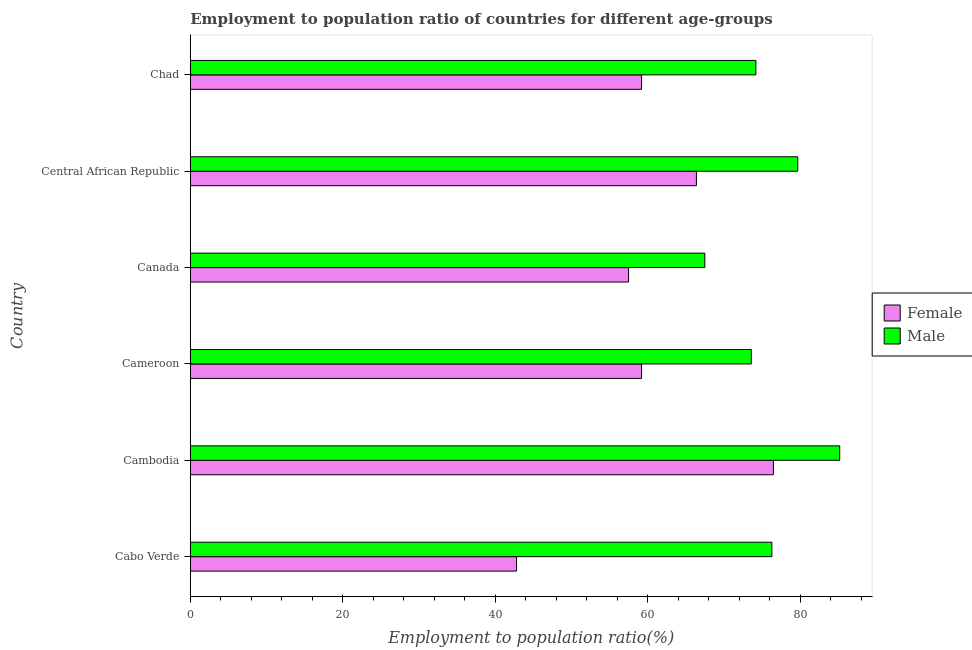Are the number of bars per tick equal to the number of legend labels?
Offer a very short reply. Yes. Are the number of bars on each tick of the Y-axis equal?
Make the answer very short. Yes. How many bars are there on the 4th tick from the bottom?
Provide a short and direct response. 2. What is the label of the 6th group of bars from the top?
Give a very brief answer. Cabo Verde. In how many cases, is the number of bars for a given country not equal to the number of legend labels?
Make the answer very short. 0. What is the employment to population ratio(female) in Cabo Verde?
Ensure brevity in your answer.  42.8. Across all countries, what is the maximum employment to population ratio(male)?
Ensure brevity in your answer.  85.2. Across all countries, what is the minimum employment to population ratio(male)?
Provide a succinct answer. 67.5. In which country was the employment to population ratio(male) maximum?
Keep it short and to the point. Cambodia. In which country was the employment to population ratio(male) minimum?
Your answer should be compact. Canada. What is the total employment to population ratio(male) in the graph?
Make the answer very short. 456.5. What is the difference between the employment to population ratio(female) in Central African Republic and the employment to population ratio(male) in Cambodia?
Your answer should be compact. -18.8. What is the average employment to population ratio(female) per country?
Provide a short and direct response. 60.27. What is the difference between the employment to population ratio(male) and employment to population ratio(female) in Cabo Verde?
Provide a succinct answer. 33.5. What is the ratio of the employment to population ratio(female) in Cabo Verde to that in Central African Republic?
Ensure brevity in your answer.  0.65. Is the employment to population ratio(female) in Cabo Verde less than that in Cameroon?
Ensure brevity in your answer.  Yes. Is the difference between the employment to population ratio(male) in Cabo Verde and Canada greater than the difference between the employment to population ratio(female) in Cabo Verde and Canada?
Give a very brief answer. Yes. What is the difference between the highest and the second highest employment to population ratio(male)?
Provide a short and direct response. 5.5. Is the sum of the employment to population ratio(female) in Cambodia and Canada greater than the maximum employment to population ratio(male) across all countries?
Ensure brevity in your answer.  Yes. How many countries are there in the graph?
Make the answer very short. 6. What is the difference between two consecutive major ticks on the X-axis?
Provide a short and direct response. 20. Are the values on the major ticks of X-axis written in scientific E-notation?
Keep it short and to the point. No. Does the graph contain grids?
Your response must be concise. No. Where does the legend appear in the graph?
Your answer should be very brief. Center right. How many legend labels are there?
Your answer should be compact. 2. What is the title of the graph?
Give a very brief answer. Employment to population ratio of countries for different age-groups. What is the label or title of the X-axis?
Ensure brevity in your answer.  Employment to population ratio(%). What is the label or title of the Y-axis?
Your response must be concise. Country. What is the Employment to population ratio(%) in Female in Cabo Verde?
Give a very brief answer. 42.8. What is the Employment to population ratio(%) in Male in Cabo Verde?
Keep it short and to the point. 76.3. What is the Employment to population ratio(%) of Female in Cambodia?
Offer a terse response. 76.5. What is the Employment to population ratio(%) in Male in Cambodia?
Offer a terse response. 85.2. What is the Employment to population ratio(%) of Female in Cameroon?
Give a very brief answer. 59.2. What is the Employment to population ratio(%) of Male in Cameroon?
Provide a succinct answer. 73.6. What is the Employment to population ratio(%) in Female in Canada?
Your answer should be very brief. 57.5. What is the Employment to population ratio(%) of Male in Canada?
Keep it short and to the point. 67.5. What is the Employment to population ratio(%) of Female in Central African Republic?
Make the answer very short. 66.4. What is the Employment to population ratio(%) of Male in Central African Republic?
Offer a terse response. 79.7. What is the Employment to population ratio(%) of Female in Chad?
Your answer should be very brief. 59.2. What is the Employment to population ratio(%) in Male in Chad?
Your response must be concise. 74.2. Across all countries, what is the maximum Employment to population ratio(%) in Female?
Your answer should be compact. 76.5. Across all countries, what is the maximum Employment to population ratio(%) in Male?
Offer a terse response. 85.2. Across all countries, what is the minimum Employment to population ratio(%) in Female?
Give a very brief answer. 42.8. Across all countries, what is the minimum Employment to population ratio(%) in Male?
Your answer should be very brief. 67.5. What is the total Employment to population ratio(%) in Female in the graph?
Your response must be concise. 361.6. What is the total Employment to population ratio(%) in Male in the graph?
Offer a terse response. 456.5. What is the difference between the Employment to population ratio(%) in Female in Cabo Verde and that in Cambodia?
Provide a short and direct response. -33.7. What is the difference between the Employment to population ratio(%) in Female in Cabo Verde and that in Cameroon?
Provide a succinct answer. -16.4. What is the difference between the Employment to population ratio(%) of Male in Cabo Verde and that in Cameroon?
Give a very brief answer. 2.7. What is the difference between the Employment to population ratio(%) in Female in Cabo Verde and that in Canada?
Ensure brevity in your answer.  -14.7. What is the difference between the Employment to population ratio(%) in Male in Cabo Verde and that in Canada?
Provide a short and direct response. 8.8. What is the difference between the Employment to population ratio(%) of Female in Cabo Verde and that in Central African Republic?
Offer a very short reply. -23.6. What is the difference between the Employment to population ratio(%) in Female in Cabo Verde and that in Chad?
Your answer should be very brief. -16.4. What is the difference between the Employment to population ratio(%) in Male in Cabo Verde and that in Chad?
Offer a terse response. 2.1. What is the difference between the Employment to population ratio(%) in Male in Cambodia and that in Canada?
Keep it short and to the point. 17.7. What is the difference between the Employment to population ratio(%) in Male in Cambodia and that in Central African Republic?
Give a very brief answer. 5.5. What is the difference between the Employment to population ratio(%) in Female in Cambodia and that in Chad?
Provide a short and direct response. 17.3. What is the difference between the Employment to population ratio(%) of Male in Cambodia and that in Chad?
Provide a succinct answer. 11. What is the difference between the Employment to population ratio(%) of Male in Cameroon and that in Canada?
Give a very brief answer. 6.1. What is the difference between the Employment to population ratio(%) in Female in Canada and that in Central African Republic?
Your response must be concise. -8.9. What is the difference between the Employment to population ratio(%) of Male in Canada and that in Central African Republic?
Give a very brief answer. -12.2. What is the difference between the Employment to population ratio(%) of Female in Central African Republic and that in Chad?
Give a very brief answer. 7.2. What is the difference between the Employment to population ratio(%) of Male in Central African Republic and that in Chad?
Ensure brevity in your answer.  5.5. What is the difference between the Employment to population ratio(%) in Female in Cabo Verde and the Employment to population ratio(%) in Male in Cambodia?
Provide a succinct answer. -42.4. What is the difference between the Employment to population ratio(%) in Female in Cabo Verde and the Employment to population ratio(%) in Male in Cameroon?
Provide a short and direct response. -30.8. What is the difference between the Employment to population ratio(%) in Female in Cabo Verde and the Employment to population ratio(%) in Male in Canada?
Give a very brief answer. -24.7. What is the difference between the Employment to population ratio(%) in Female in Cabo Verde and the Employment to population ratio(%) in Male in Central African Republic?
Your response must be concise. -36.9. What is the difference between the Employment to population ratio(%) in Female in Cabo Verde and the Employment to population ratio(%) in Male in Chad?
Keep it short and to the point. -31.4. What is the difference between the Employment to population ratio(%) of Female in Cambodia and the Employment to population ratio(%) of Male in Central African Republic?
Make the answer very short. -3.2. What is the difference between the Employment to population ratio(%) in Female in Cambodia and the Employment to population ratio(%) in Male in Chad?
Make the answer very short. 2.3. What is the difference between the Employment to population ratio(%) of Female in Cameroon and the Employment to population ratio(%) of Male in Central African Republic?
Your response must be concise. -20.5. What is the difference between the Employment to population ratio(%) of Female in Canada and the Employment to population ratio(%) of Male in Central African Republic?
Give a very brief answer. -22.2. What is the difference between the Employment to population ratio(%) in Female in Canada and the Employment to population ratio(%) in Male in Chad?
Offer a terse response. -16.7. What is the difference between the Employment to population ratio(%) in Female in Central African Republic and the Employment to population ratio(%) in Male in Chad?
Your answer should be very brief. -7.8. What is the average Employment to population ratio(%) in Female per country?
Make the answer very short. 60.27. What is the average Employment to population ratio(%) in Male per country?
Your response must be concise. 76.08. What is the difference between the Employment to population ratio(%) in Female and Employment to population ratio(%) in Male in Cabo Verde?
Offer a very short reply. -33.5. What is the difference between the Employment to population ratio(%) of Female and Employment to population ratio(%) of Male in Cameroon?
Offer a very short reply. -14.4. What is the difference between the Employment to population ratio(%) of Female and Employment to population ratio(%) of Male in Central African Republic?
Your answer should be very brief. -13.3. What is the ratio of the Employment to population ratio(%) in Female in Cabo Verde to that in Cambodia?
Keep it short and to the point. 0.56. What is the ratio of the Employment to population ratio(%) of Male in Cabo Verde to that in Cambodia?
Your response must be concise. 0.9. What is the ratio of the Employment to population ratio(%) of Female in Cabo Verde to that in Cameroon?
Provide a short and direct response. 0.72. What is the ratio of the Employment to population ratio(%) in Male in Cabo Verde to that in Cameroon?
Your answer should be compact. 1.04. What is the ratio of the Employment to population ratio(%) in Female in Cabo Verde to that in Canada?
Provide a succinct answer. 0.74. What is the ratio of the Employment to population ratio(%) in Male in Cabo Verde to that in Canada?
Your response must be concise. 1.13. What is the ratio of the Employment to population ratio(%) in Female in Cabo Verde to that in Central African Republic?
Provide a succinct answer. 0.64. What is the ratio of the Employment to population ratio(%) of Male in Cabo Verde to that in Central African Republic?
Give a very brief answer. 0.96. What is the ratio of the Employment to population ratio(%) of Female in Cabo Verde to that in Chad?
Offer a terse response. 0.72. What is the ratio of the Employment to population ratio(%) in Male in Cabo Verde to that in Chad?
Provide a succinct answer. 1.03. What is the ratio of the Employment to population ratio(%) in Female in Cambodia to that in Cameroon?
Provide a succinct answer. 1.29. What is the ratio of the Employment to population ratio(%) in Male in Cambodia to that in Cameroon?
Your answer should be compact. 1.16. What is the ratio of the Employment to population ratio(%) of Female in Cambodia to that in Canada?
Your response must be concise. 1.33. What is the ratio of the Employment to population ratio(%) of Male in Cambodia to that in Canada?
Provide a short and direct response. 1.26. What is the ratio of the Employment to population ratio(%) of Female in Cambodia to that in Central African Republic?
Provide a short and direct response. 1.15. What is the ratio of the Employment to population ratio(%) in Male in Cambodia to that in Central African Republic?
Ensure brevity in your answer.  1.07. What is the ratio of the Employment to population ratio(%) in Female in Cambodia to that in Chad?
Your answer should be very brief. 1.29. What is the ratio of the Employment to population ratio(%) of Male in Cambodia to that in Chad?
Your response must be concise. 1.15. What is the ratio of the Employment to population ratio(%) in Female in Cameroon to that in Canada?
Provide a short and direct response. 1.03. What is the ratio of the Employment to population ratio(%) of Male in Cameroon to that in Canada?
Your response must be concise. 1.09. What is the ratio of the Employment to population ratio(%) of Female in Cameroon to that in Central African Republic?
Give a very brief answer. 0.89. What is the ratio of the Employment to population ratio(%) of Male in Cameroon to that in Central African Republic?
Offer a very short reply. 0.92. What is the ratio of the Employment to population ratio(%) of Female in Cameroon to that in Chad?
Provide a succinct answer. 1. What is the ratio of the Employment to population ratio(%) in Male in Cameroon to that in Chad?
Ensure brevity in your answer.  0.99. What is the ratio of the Employment to population ratio(%) of Female in Canada to that in Central African Republic?
Your response must be concise. 0.87. What is the ratio of the Employment to population ratio(%) in Male in Canada to that in Central African Republic?
Provide a short and direct response. 0.85. What is the ratio of the Employment to population ratio(%) of Female in Canada to that in Chad?
Ensure brevity in your answer.  0.97. What is the ratio of the Employment to population ratio(%) in Male in Canada to that in Chad?
Your response must be concise. 0.91. What is the ratio of the Employment to population ratio(%) in Female in Central African Republic to that in Chad?
Offer a very short reply. 1.12. What is the ratio of the Employment to population ratio(%) of Male in Central African Republic to that in Chad?
Your response must be concise. 1.07. What is the difference between the highest and the lowest Employment to population ratio(%) in Female?
Your answer should be compact. 33.7. What is the difference between the highest and the lowest Employment to population ratio(%) of Male?
Provide a short and direct response. 17.7. 